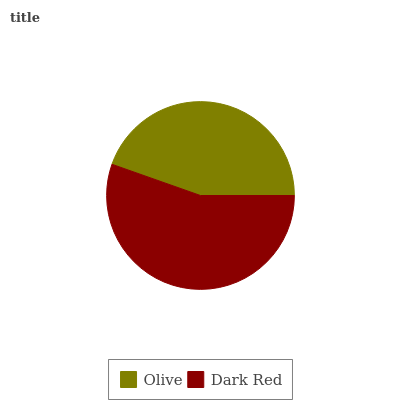Is Olive the minimum?
Answer yes or no. Yes. Is Dark Red the maximum?
Answer yes or no. Yes. Is Dark Red the minimum?
Answer yes or no. No. Is Dark Red greater than Olive?
Answer yes or no. Yes. Is Olive less than Dark Red?
Answer yes or no. Yes. Is Olive greater than Dark Red?
Answer yes or no. No. Is Dark Red less than Olive?
Answer yes or no. No. Is Dark Red the high median?
Answer yes or no. Yes. Is Olive the low median?
Answer yes or no. Yes. Is Olive the high median?
Answer yes or no. No. Is Dark Red the low median?
Answer yes or no. No. 